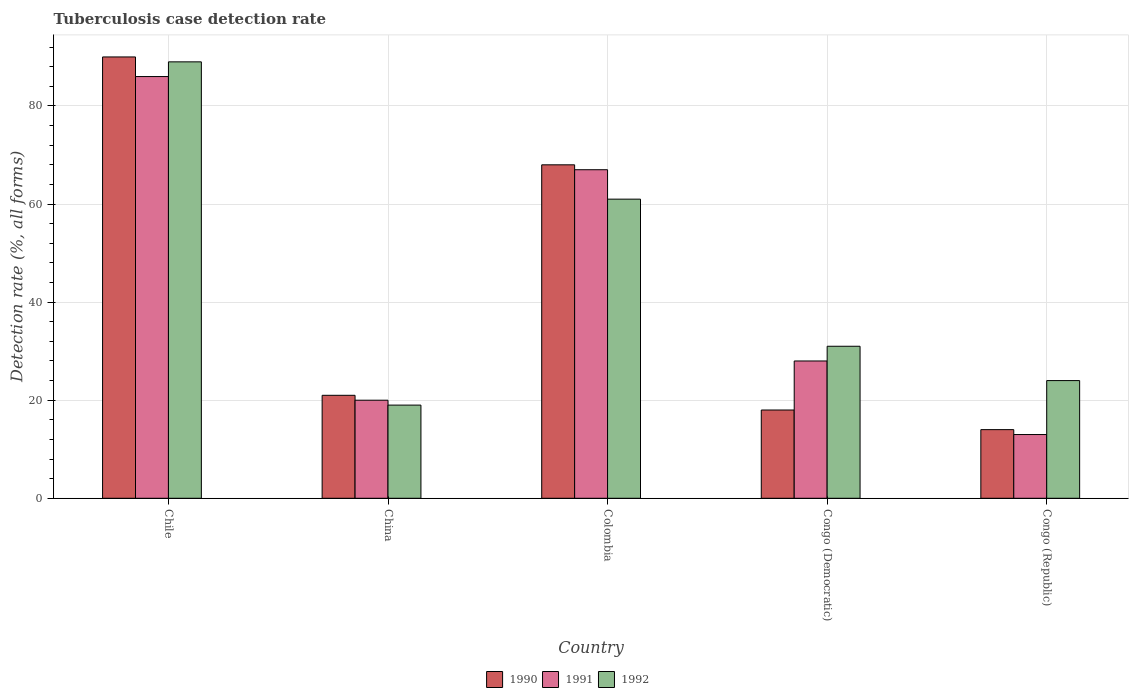How many groups of bars are there?
Make the answer very short. 5. Are the number of bars on each tick of the X-axis equal?
Your answer should be very brief. Yes. How many bars are there on the 1st tick from the left?
Make the answer very short. 3. What is the label of the 2nd group of bars from the left?
Your answer should be very brief. China. In how many cases, is the number of bars for a given country not equal to the number of legend labels?
Keep it short and to the point. 0. Across all countries, what is the maximum tuberculosis case detection rate in in 1991?
Ensure brevity in your answer.  86. Across all countries, what is the minimum tuberculosis case detection rate in in 1990?
Provide a short and direct response. 14. In which country was the tuberculosis case detection rate in in 1991 minimum?
Provide a succinct answer. Congo (Republic). What is the total tuberculosis case detection rate in in 1991 in the graph?
Your answer should be very brief. 214. What is the difference between the tuberculosis case detection rate in in 1990 in Chile and that in Congo (Republic)?
Provide a succinct answer. 76. What is the average tuberculosis case detection rate in in 1992 per country?
Offer a terse response. 44.8. What is the ratio of the tuberculosis case detection rate in in 1992 in Chile to that in Congo (Republic)?
Keep it short and to the point. 3.71. What is the difference between the highest and the lowest tuberculosis case detection rate in in 1990?
Your answer should be compact. 76. Is the sum of the tuberculosis case detection rate in in 1991 in China and Congo (Democratic) greater than the maximum tuberculosis case detection rate in in 1992 across all countries?
Offer a terse response. No. Is it the case that in every country, the sum of the tuberculosis case detection rate in in 1990 and tuberculosis case detection rate in in 1991 is greater than the tuberculosis case detection rate in in 1992?
Your answer should be very brief. Yes. What is the difference between two consecutive major ticks on the Y-axis?
Offer a terse response. 20. Are the values on the major ticks of Y-axis written in scientific E-notation?
Give a very brief answer. No. Does the graph contain any zero values?
Keep it short and to the point. No. Where does the legend appear in the graph?
Provide a short and direct response. Bottom center. How many legend labels are there?
Provide a succinct answer. 3. How are the legend labels stacked?
Give a very brief answer. Horizontal. What is the title of the graph?
Your response must be concise. Tuberculosis case detection rate. Does "1985" appear as one of the legend labels in the graph?
Your response must be concise. No. What is the label or title of the Y-axis?
Your answer should be very brief. Detection rate (%, all forms). What is the Detection rate (%, all forms) in 1991 in Chile?
Offer a terse response. 86. What is the Detection rate (%, all forms) of 1992 in Chile?
Provide a succinct answer. 89. What is the Detection rate (%, all forms) of 1990 in China?
Your answer should be compact. 21. What is the Detection rate (%, all forms) in 1992 in China?
Ensure brevity in your answer.  19. What is the Detection rate (%, all forms) of 1990 in Colombia?
Provide a succinct answer. 68. What is the Detection rate (%, all forms) in 1992 in Colombia?
Offer a very short reply. 61. What is the Detection rate (%, all forms) in 1990 in Congo (Democratic)?
Make the answer very short. 18. What is the Detection rate (%, all forms) of 1991 in Congo (Democratic)?
Provide a succinct answer. 28. What is the Detection rate (%, all forms) of 1992 in Congo (Democratic)?
Offer a terse response. 31. What is the Detection rate (%, all forms) in 1990 in Congo (Republic)?
Offer a terse response. 14. What is the Detection rate (%, all forms) of 1991 in Congo (Republic)?
Your answer should be compact. 13. What is the Detection rate (%, all forms) in 1992 in Congo (Republic)?
Your answer should be compact. 24. Across all countries, what is the maximum Detection rate (%, all forms) of 1990?
Your answer should be compact. 90. Across all countries, what is the maximum Detection rate (%, all forms) in 1992?
Your answer should be compact. 89. Across all countries, what is the minimum Detection rate (%, all forms) of 1992?
Your response must be concise. 19. What is the total Detection rate (%, all forms) of 1990 in the graph?
Provide a succinct answer. 211. What is the total Detection rate (%, all forms) of 1991 in the graph?
Ensure brevity in your answer.  214. What is the total Detection rate (%, all forms) of 1992 in the graph?
Give a very brief answer. 224. What is the difference between the Detection rate (%, all forms) in 1990 in Chile and that in China?
Ensure brevity in your answer.  69. What is the difference between the Detection rate (%, all forms) in 1990 in Chile and that in Colombia?
Provide a short and direct response. 22. What is the difference between the Detection rate (%, all forms) of 1991 in Chile and that in Colombia?
Provide a short and direct response. 19. What is the difference between the Detection rate (%, all forms) of 1992 in Chile and that in Colombia?
Your response must be concise. 28. What is the difference between the Detection rate (%, all forms) of 1992 in Chile and that in Congo (Democratic)?
Offer a very short reply. 58. What is the difference between the Detection rate (%, all forms) of 1990 in Chile and that in Congo (Republic)?
Keep it short and to the point. 76. What is the difference between the Detection rate (%, all forms) in 1990 in China and that in Colombia?
Ensure brevity in your answer.  -47. What is the difference between the Detection rate (%, all forms) of 1991 in China and that in Colombia?
Provide a short and direct response. -47. What is the difference between the Detection rate (%, all forms) in 1992 in China and that in Colombia?
Offer a very short reply. -42. What is the difference between the Detection rate (%, all forms) of 1990 in China and that in Congo (Democratic)?
Provide a short and direct response. 3. What is the difference between the Detection rate (%, all forms) in 1991 in China and that in Congo (Democratic)?
Offer a very short reply. -8. What is the difference between the Detection rate (%, all forms) in 1992 in China and that in Congo (Republic)?
Give a very brief answer. -5. What is the difference between the Detection rate (%, all forms) of 1991 in Colombia and that in Congo (Democratic)?
Provide a short and direct response. 39. What is the difference between the Detection rate (%, all forms) in 1992 in Colombia and that in Congo (Democratic)?
Keep it short and to the point. 30. What is the difference between the Detection rate (%, all forms) in 1991 in Colombia and that in Congo (Republic)?
Your response must be concise. 54. What is the difference between the Detection rate (%, all forms) in 1990 in Chile and the Detection rate (%, all forms) in 1992 in China?
Ensure brevity in your answer.  71. What is the difference between the Detection rate (%, all forms) of 1991 in Chile and the Detection rate (%, all forms) of 1992 in China?
Make the answer very short. 67. What is the difference between the Detection rate (%, all forms) in 1990 in Chile and the Detection rate (%, all forms) in 1991 in Colombia?
Offer a very short reply. 23. What is the difference between the Detection rate (%, all forms) of 1991 in Chile and the Detection rate (%, all forms) of 1992 in Colombia?
Offer a terse response. 25. What is the difference between the Detection rate (%, all forms) of 1990 in Chile and the Detection rate (%, all forms) of 1991 in Congo (Republic)?
Keep it short and to the point. 77. What is the difference between the Detection rate (%, all forms) of 1990 in Chile and the Detection rate (%, all forms) of 1992 in Congo (Republic)?
Your answer should be compact. 66. What is the difference between the Detection rate (%, all forms) of 1991 in Chile and the Detection rate (%, all forms) of 1992 in Congo (Republic)?
Your answer should be compact. 62. What is the difference between the Detection rate (%, all forms) in 1990 in China and the Detection rate (%, all forms) in 1991 in Colombia?
Give a very brief answer. -46. What is the difference between the Detection rate (%, all forms) in 1991 in China and the Detection rate (%, all forms) in 1992 in Colombia?
Make the answer very short. -41. What is the difference between the Detection rate (%, all forms) in 1990 in China and the Detection rate (%, all forms) in 1992 in Congo (Democratic)?
Ensure brevity in your answer.  -10. What is the difference between the Detection rate (%, all forms) in 1990 in Colombia and the Detection rate (%, all forms) in 1991 in Congo (Democratic)?
Your answer should be compact. 40. What is the difference between the Detection rate (%, all forms) of 1990 in Colombia and the Detection rate (%, all forms) of 1992 in Congo (Democratic)?
Offer a terse response. 37. What is the difference between the Detection rate (%, all forms) in 1990 in Colombia and the Detection rate (%, all forms) in 1992 in Congo (Republic)?
Provide a succinct answer. 44. What is the difference between the Detection rate (%, all forms) in 1990 in Congo (Democratic) and the Detection rate (%, all forms) in 1992 in Congo (Republic)?
Offer a terse response. -6. What is the difference between the Detection rate (%, all forms) of 1991 in Congo (Democratic) and the Detection rate (%, all forms) of 1992 in Congo (Republic)?
Your answer should be very brief. 4. What is the average Detection rate (%, all forms) in 1990 per country?
Offer a very short reply. 42.2. What is the average Detection rate (%, all forms) of 1991 per country?
Ensure brevity in your answer.  42.8. What is the average Detection rate (%, all forms) of 1992 per country?
Provide a short and direct response. 44.8. What is the difference between the Detection rate (%, all forms) of 1990 and Detection rate (%, all forms) of 1991 in Chile?
Give a very brief answer. 4. What is the difference between the Detection rate (%, all forms) in 1990 and Detection rate (%, all forms) in 1992 in Chile?
Ensure brevity in your answer.  1. What is the difference between the Detection rate (%, all forms) of 1991 and Detection rate (%, all forms) of 1992 in Chile?
Make the answer very short. -3. What is the difference between the Detection rate (%, all forms) of 1990 and Detection rate (%, all forms) of 1991 in China?
Keep it short and to the point. 1. What is the difference between the Detection rate (%, all forms) in 1990 and Detection rate (%, all forms) in 1992 in China?
Provide a succinct answer. 2. What is the difference between the Detection rate (%, all forms) of 1991 and Detection rate (%, all forms) of 1992 in China?
Your response must be concise. 1. What is the difference between the Detection rate (%, all forms) of 1991 and Detection rate (%, all forms) of 1992 in Colombia?
Offer a terse response. 6. What is the difference between the Detection rate (%, all forms) of 1990 and Detection rate (%, all forms) of 1991 in Congo (Democratic)?
Your response must be concise. -10. What is the ratio of the Detection rate (%, all forms) in 1990 in Chile to that in China?
Provide a succinct answer. 4.29. What is the ratio of the Detection rate (%, all forms) in 1992 in Chile to that in China?
Your answer should be compact. 4.68. What is the ratio of the Detection rate (%, all forms) of 1990 in Chile to that in Colombia?
Ensure brevity in your answer.  1.32. What is the ratio of the Detection rate (%, all forms) of 1991 in Chile to that in Colombia?
Make the answer very short. 1.28. What is the ratio of the Detection rate (%, all forms) of 1992 in Chile to that in Colombia?
Your response must be concise. 1.46. What is the ratio of the Detection rate (%, all forms) of 1991 in Chile to that in Congo (Democratic)?
Make the answer very short. 3.07. What is the ratio of the Detection rate (%, all forms) of 1992 in Chile to that in Congo (Democratic)?
Your answer should be very brief. 2.87. What is the ratio of the Detection rate (%, all forms) of 1990 in Chile to that in Congo (Republic)?
Your answer should be very brief. 6.43. What is the ratio of the Detection rate (%, all forms) in 1991 in Chile to that in Congo (Republic)?
Ensure brevity in your answer.  6.62. What is the ratio of the Detection rate (%, all forms) in 1992 in Chile to that in Congo (Republic)?
Your answer should be compact. 3.71. What is the ratio of the Detection rate (%, all forms) in 1990 in China to that in Colombia?
Your answer should be compact. 0.31. What is the ratio of the Detection rate (%, all forms) in 1991 in China to that in Colombia?
Give a very brief answer. 0.3. What is the ratio of the Detection rate (%, all forms) in 1992 in China to that in Colombia?
Provide a succinct answer. 0.31. What is the ratio of the Detection rate (%, all forms) of 1991 in China to that in Congo (Democratic)?
Provide a succinct answer. 0.71. What is the ratio of the Detection rate (%, all forms) in 1992 in China to that in Congo (Democratic)?
Your response must be concise. 0.61. What is the ratio of the Detection rate (%, all forms) of 1991 in China to that in Congo (Republic)?
Offer a very short reply. 1.54. What is the ratio of the Detection rate (%, all forms) of 1992 in China to that in Congo (Republic)?
Make the answer very short. 0.79. What is the ratio of the Detection rate (%, all forms) in 1990 in Colombia to that in Congo (Democratic)?
Provide a short and direct response. 3.78. What is the ratio of the Detection rate (%, all forms) in 1991 in Colombia to that in Congo (Democratic)?
Offer a terse response. 2.39. What is the ratio of the Detection rate (%, all forms) in 1992 in Colombia to that in Congo (Democratic)?
Your response must be concise. 1.97. What is the ratio of the Detection rate (%, all forms) in 1990 in Colombia to that in Congo (Republic)?
Your answer should be compact. 4.86. What is the ratio of the Detection rate (%, all forms) in 1991 in Colombia to that in Congo (Republic)?
Provide a succinct answer. 5.15. What is the ratio of the Detection rate (%, all forms) of 1992 in Colombia to that in Congo (Republic)?
Keep it short and to the point. 2.54. What is the ratio of the Detection rate (%, all forms) in 1990 in Congo (Democratic) to that in Congo (Republic)?
Give a very brief answer. 1.29. What is the ratio of the Detection rate (%, all forms) of 1991 in Congo (Democratic) to that in Congo (Republic)?
Offer a very short reply. 2.15. What is the ratio of the Detection rate (%, all forms) of 1992 in Congo (Democratic) to that in Congo (Republic)?
Ensure brevity in your answer.  1.29. What is the difference between the highest and the second highest Detection rate (%, all forms) of 1991?
Keep it short and to the point. 19. What is the difference between the highest and the second highest Detection rate (%, all forms) of 1992?
Keep it short and to the point. 28. What is the difference between the highest and the lowest Detection rate (%, all forms) of 1990?
Ensure brevity in your answer.  76. What is the difference between the highest and the lowest Detection rate (%, all forms) in 1991?
Offer a very short reply. 73. 